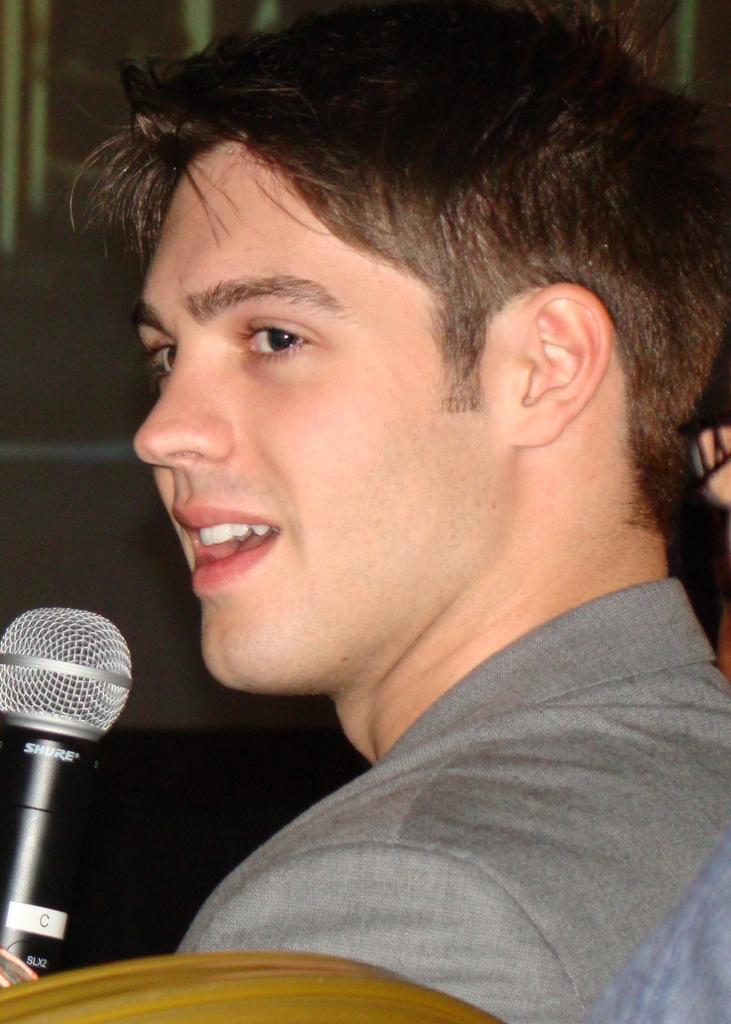Describe this image in one or two sentences. In this image there is a person wearing a blazer. He is holding a mike. Background there is a wall. Bottom of the image there is a chair. 